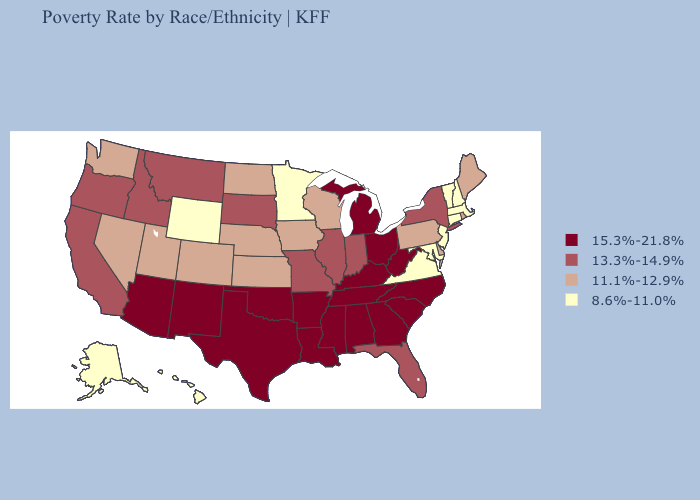Among the states that border New Jersey , does New York have the lowest value?
Answer briefly. No. What is the highest value in states that border Colorado?
Concise answer only. 15.3%-21.8%. What is the highest value in the USA?
Answer briefly. 15.3%-21.8%. Does Maine have the highest value in the Northeast?
Answer briefly. No. Name the states that have a value in the range 13.3%-14.9%?
Answer briefly. California, Florida, Idaho, Illinois, Indiana, Missouri, Montana, New York, Oregon, South Dakota. Name the states that have a value in the range 8.6%-11.0%?
Keep it brief. Alaska, Connecticut, Hawaii, Maryland, Massachusetts, Minnesota, New Hampshire, New Jersey, Vermont, Virginia, Wyoming. What is the value of New Mexico?
Short answer required. 15.3%-21.8%. Which states have the lowest value in the USA?
Quick response, please. Alaska, Connecticut, Hawaii, Maryland, Massachusetts, Minnesota, New Hampshire, New Jersey, Vermont, Virginia, Wyoming. Which states hav the highest value in the South?
Answer briefly. Alabama, Arkansas, Georgia, Kentucky, Louisiana, Mississippi, North Carolina, Oklahoma, South Carolina, Tennessee, Texas, West Virginia. Among the states that border Michigan , which have the lowest value?
Be succinct. Wisconsin. Which states have the highest value in the USA?
Write a very short answer. Alabama, Arizona, Arkansas, Georgia, Kentucky, Louisiana, Michigan, Mississippi, New Mexico, North Carolina, Ohio, Oklahoma, South Carolina, Tennessee, Texas, West Virginia. Does the map have missing data?
Write a very short answer. No. Which states have the lowest value in the West?
Short answer required. Alaska, Hawaii, Wyoming. Does West Virginia have a lower value than Indiana?
Write a very short answer. No. Among the states that border Ohio , does West Virginia have the highest value?
Concise answer only. Yes. 